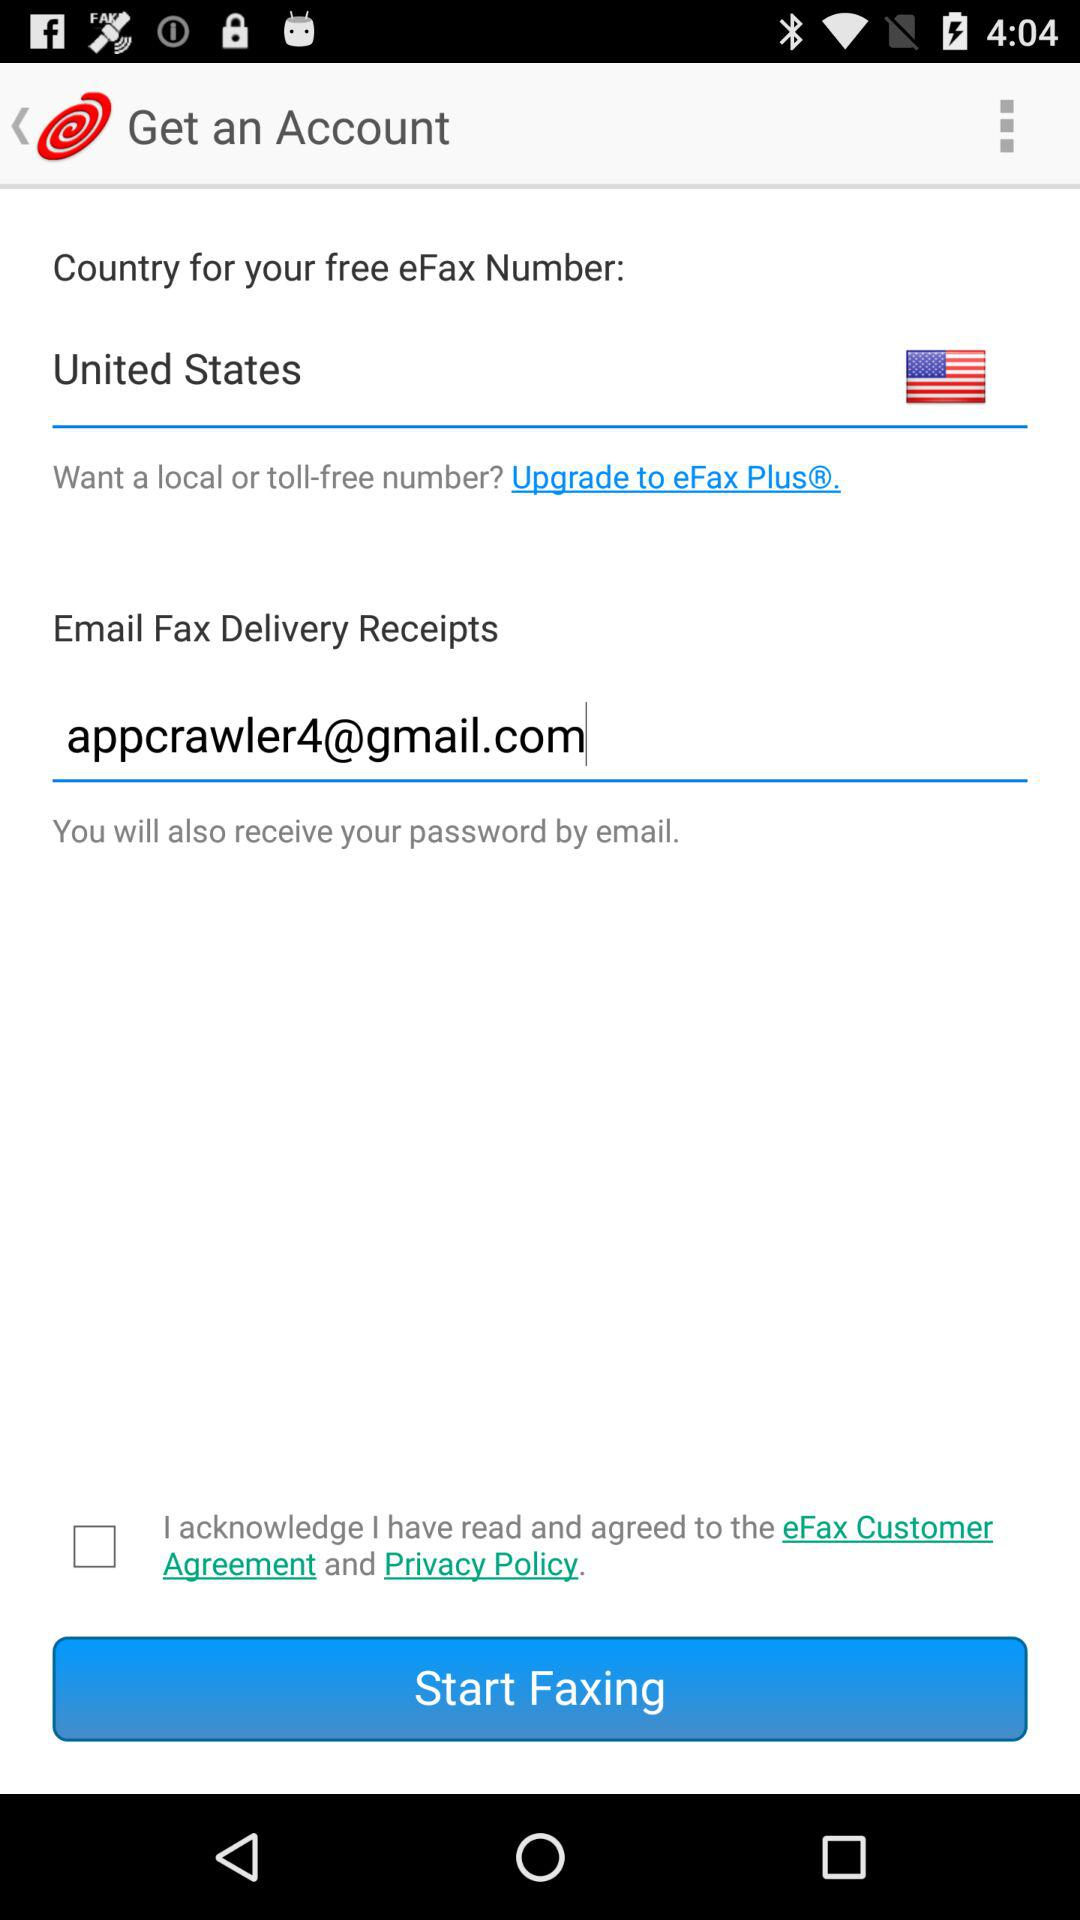What is the email address? The email address is appcrawler4@gmail.com. 